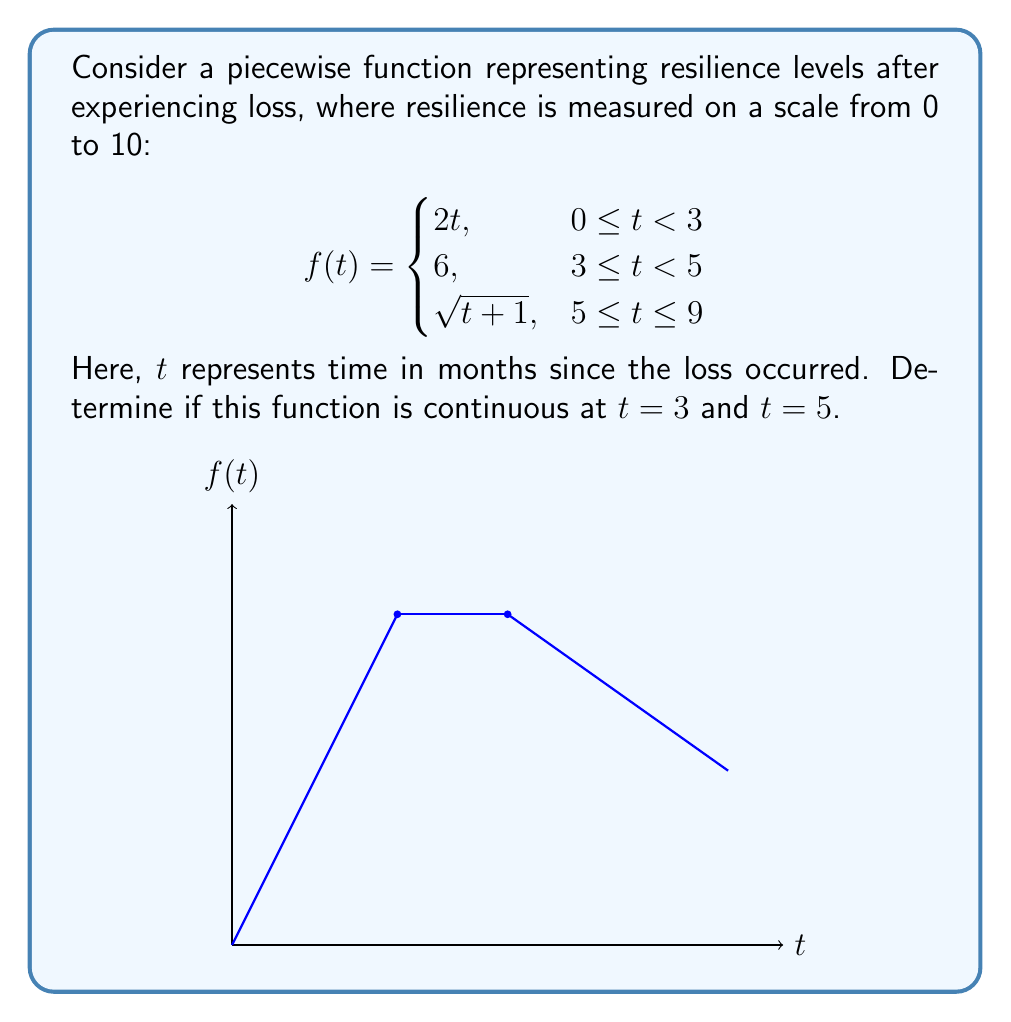Provide a solution to this math problem. To determine if the function is continuous at $t = 3$ and $t = 5$, we need to check three conditions at each point:
1. The function is defined at the point.
2. The limit of the function as we approach the point from both sides exists.
3. The limit equals the function value at that point.

For $t = 3$:
1. $f(3)$ is defined: $f(3) = 6$ (using the second piece of the function)
2. Left limit: $\lim_{t \to 3^-} f(t) = \lim_{t \to 3^-} 2t = 6$
   Right limit: $\lim_{t \to 3^+} f(t) = 6$
   Both limits exist and are equal.
3. $\lim_{t \to 3} f(t) = f(3) = 6$

All three conditions are satisfied, so $f(t)$ is continuous at $t = 3$.

For $t = 5$:
1. $f(5)$ is defined: $f(5) = \sqrt{5+1} = \sqrt{6}$
2. Left limit: $\lim_{t \to 5^-} f(t) = 6$
   Right limit: $\lim_{t \to 5^+} f(t) = \lim_{t \to 5^+} \sqrt{t+1} = \sqrt{6}$
   The limits exist but are not equal.
3. $\lim_{t \to 5^-} f(t) \neq f(5)$

The second condition is not satisfied, so $f(t)$ is not continuous at $t = 5$.
Answer: Continuous at $t = 3$, discontinuous at $t = 5$. 